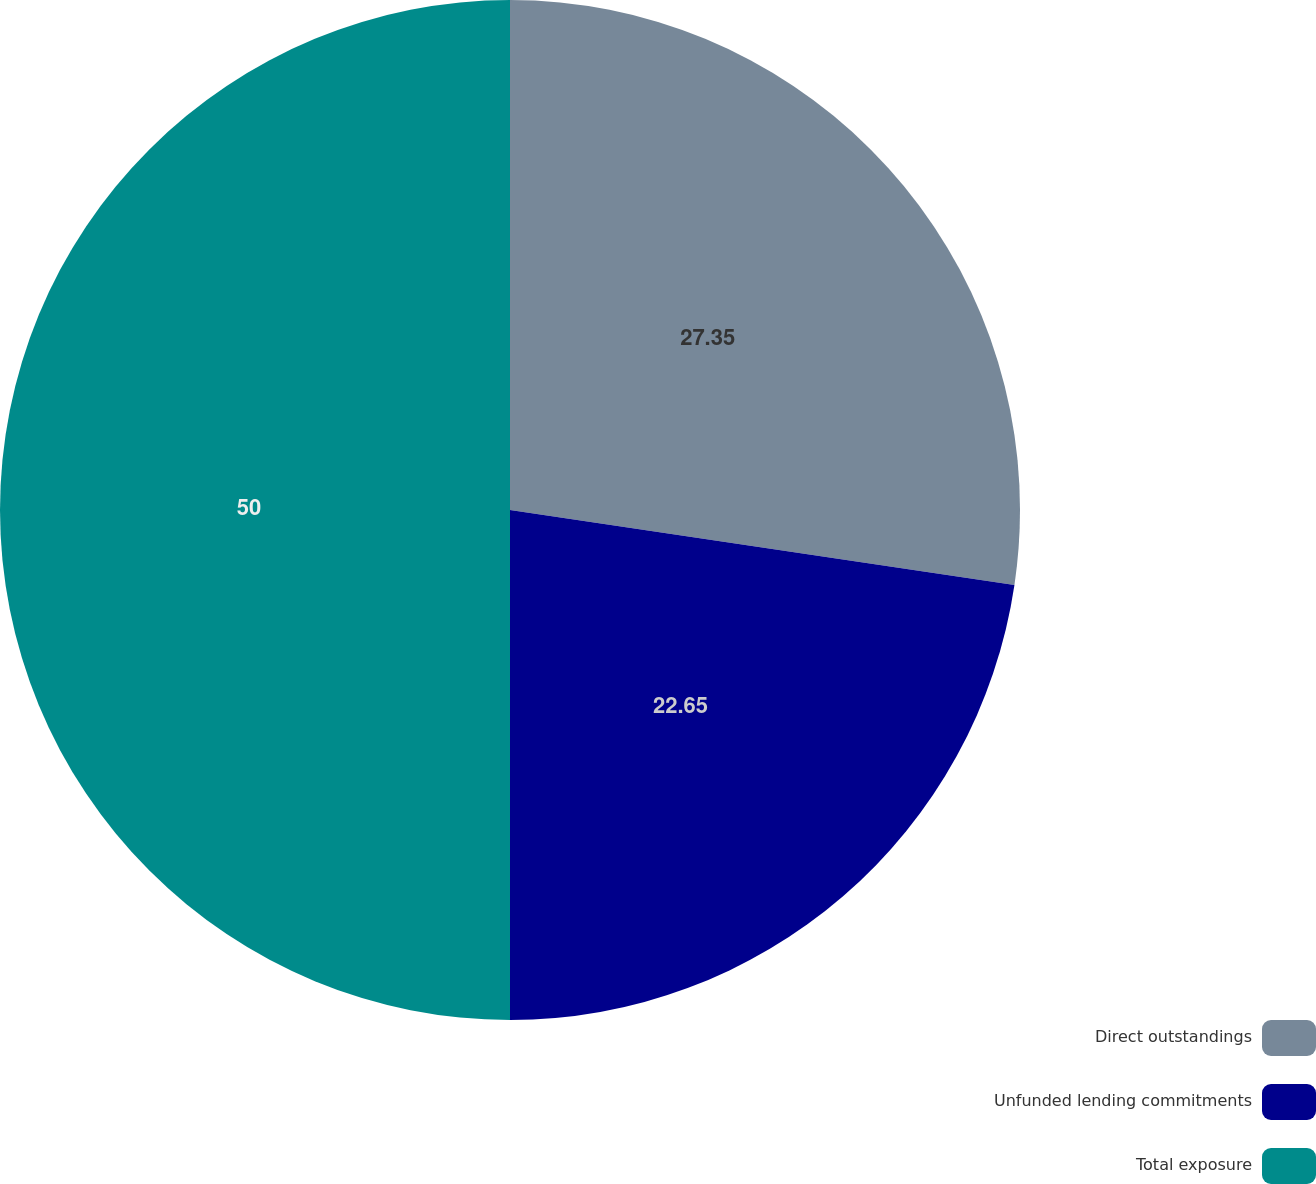Convert chart. <chart><loc_0><loc_0><loc_500><loc_500><pie_chart><fcel>Direct outstandings<fcel>Unfunded lending commitments<fcel>Total exposure<nl><fcel>27.35%<fcel>22.65%<fcel>50.0%<nl></chart> 